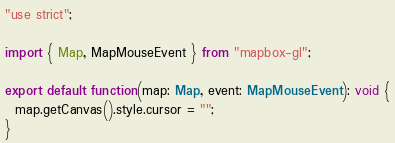Convert code to text. <code><loc_0><loc_0><loc_500><loc_500><_TypeScript_>"use strict";

import { Map, MapMouseEvent } from "mapbox-gl";

export default function(map: Map, event: MapMouseEvent): void {
  map.getCanvas().style.cursor = "";
}
</code> 